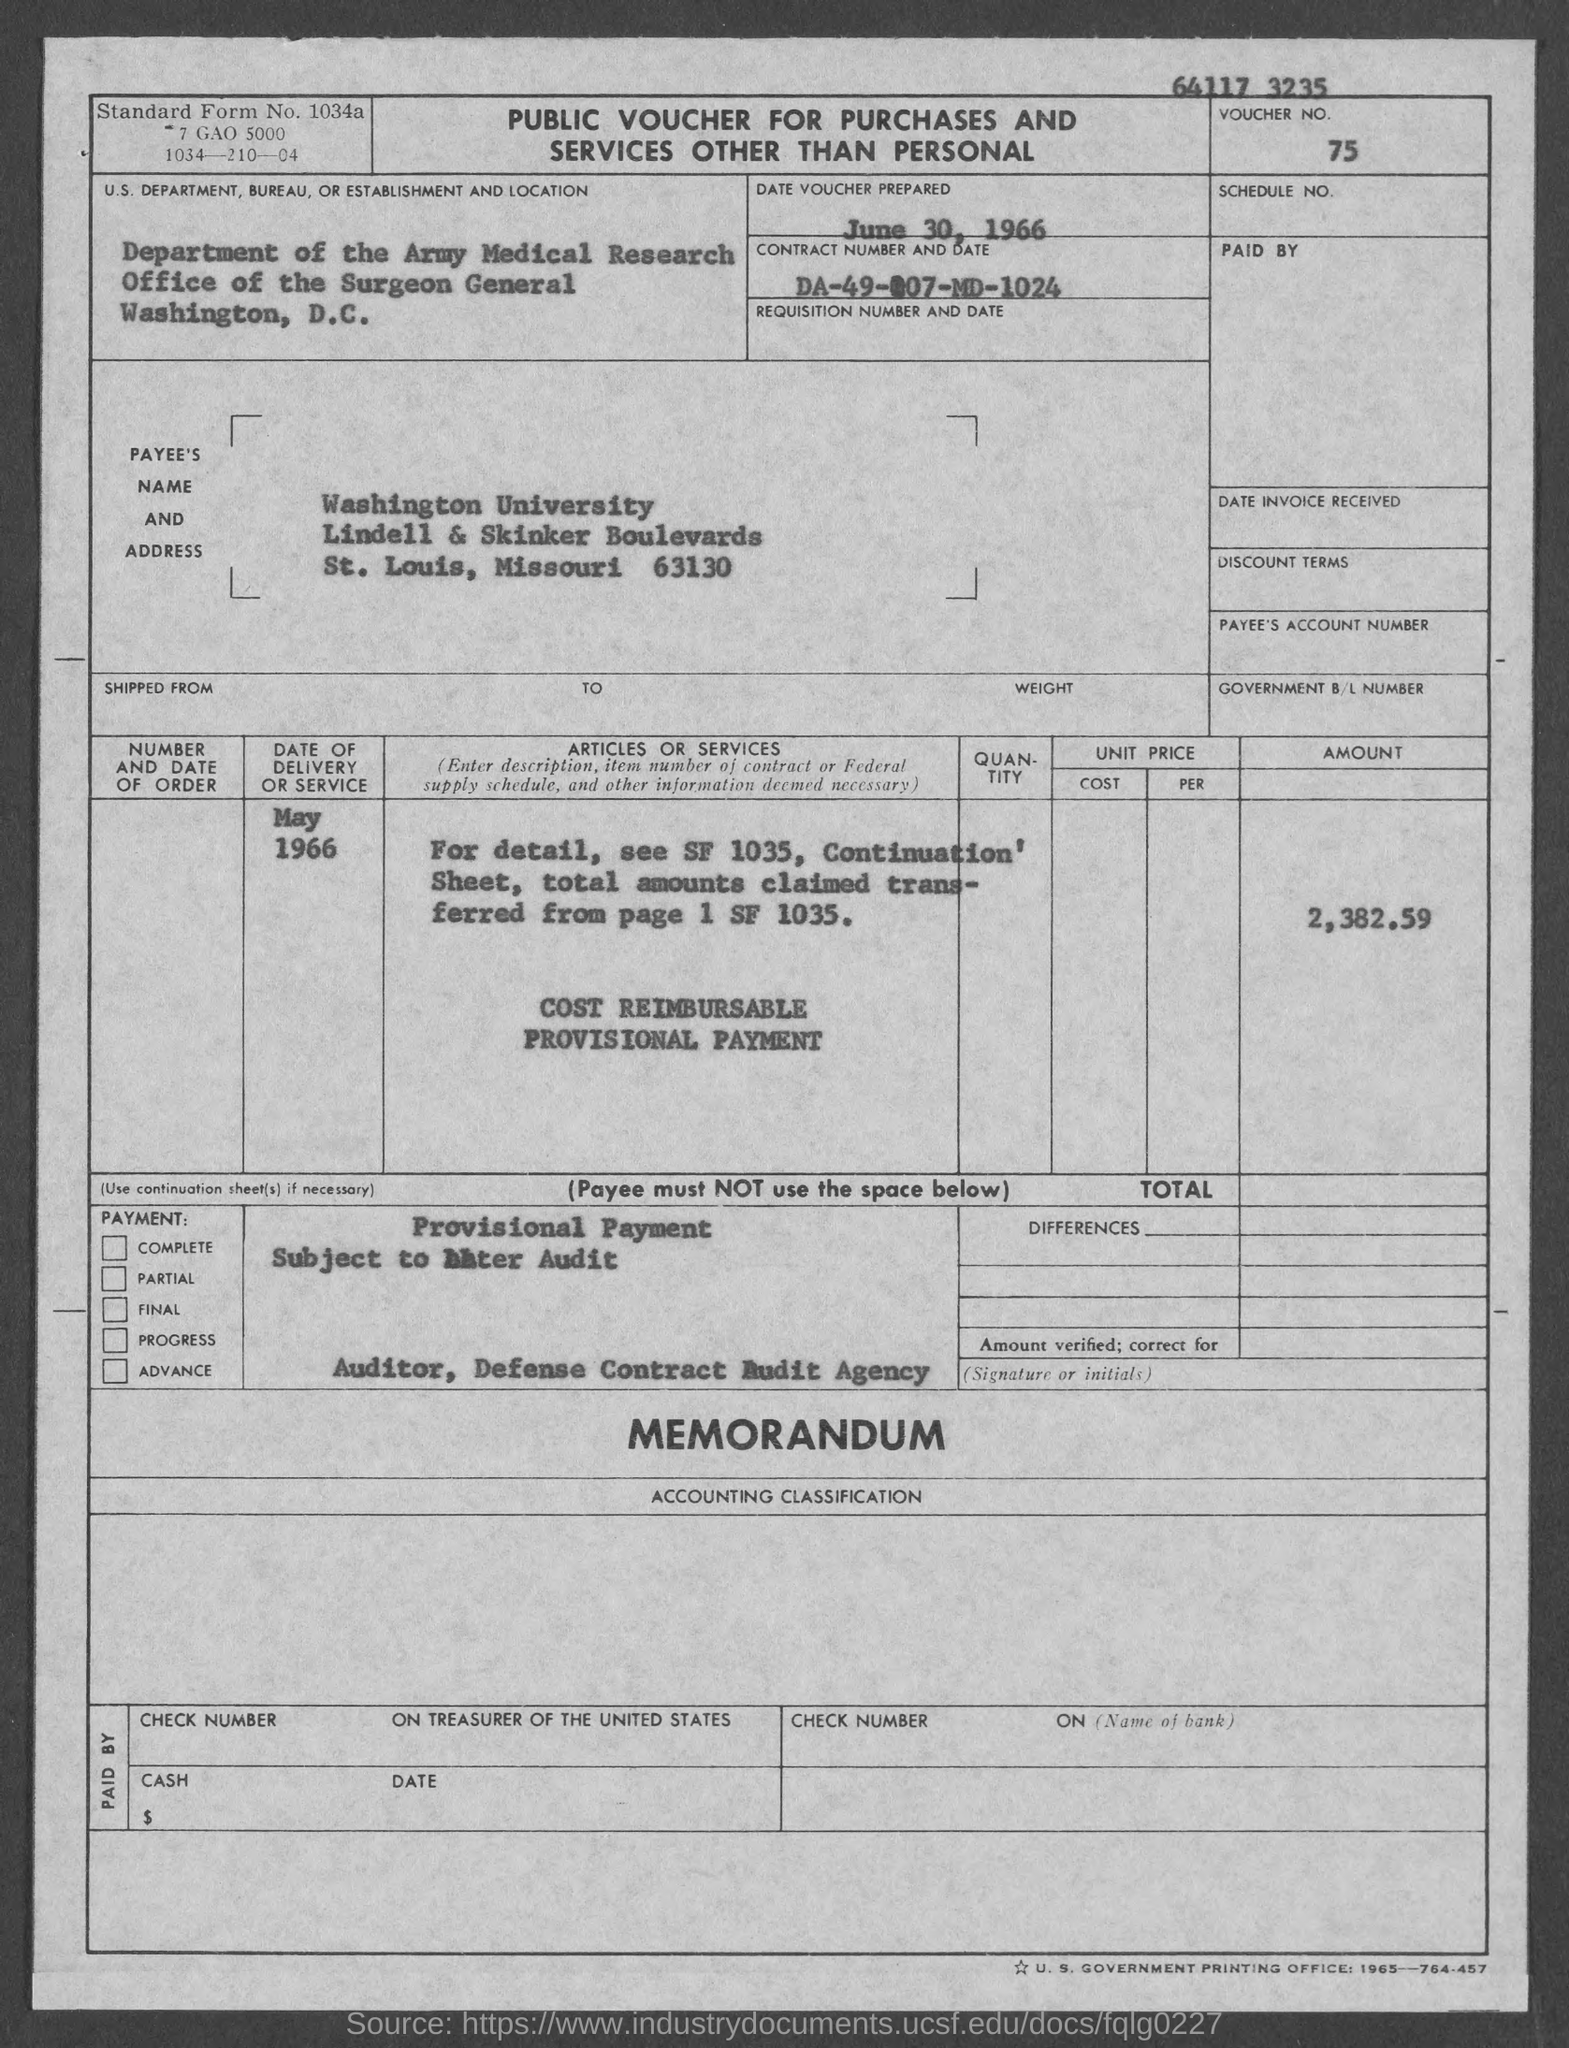What is the voucher number?
Ensure brevity in your answer.  75. What is the date voucher prepared?
Give a very brief answer. June 30, 1966. What is the contract number and date?
Your response must be concise. DA-49-007-MD-1024. What is the date of delivery or service?
Make the answer very short. May 1966. What is the amount?
Keep it short and to the point. 2,382.59. 